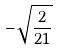<formula> <loc_0><loc_0><loc_500><loc_500>- \sqrt { \frac { 2 } { 2 1 } }</formula> 